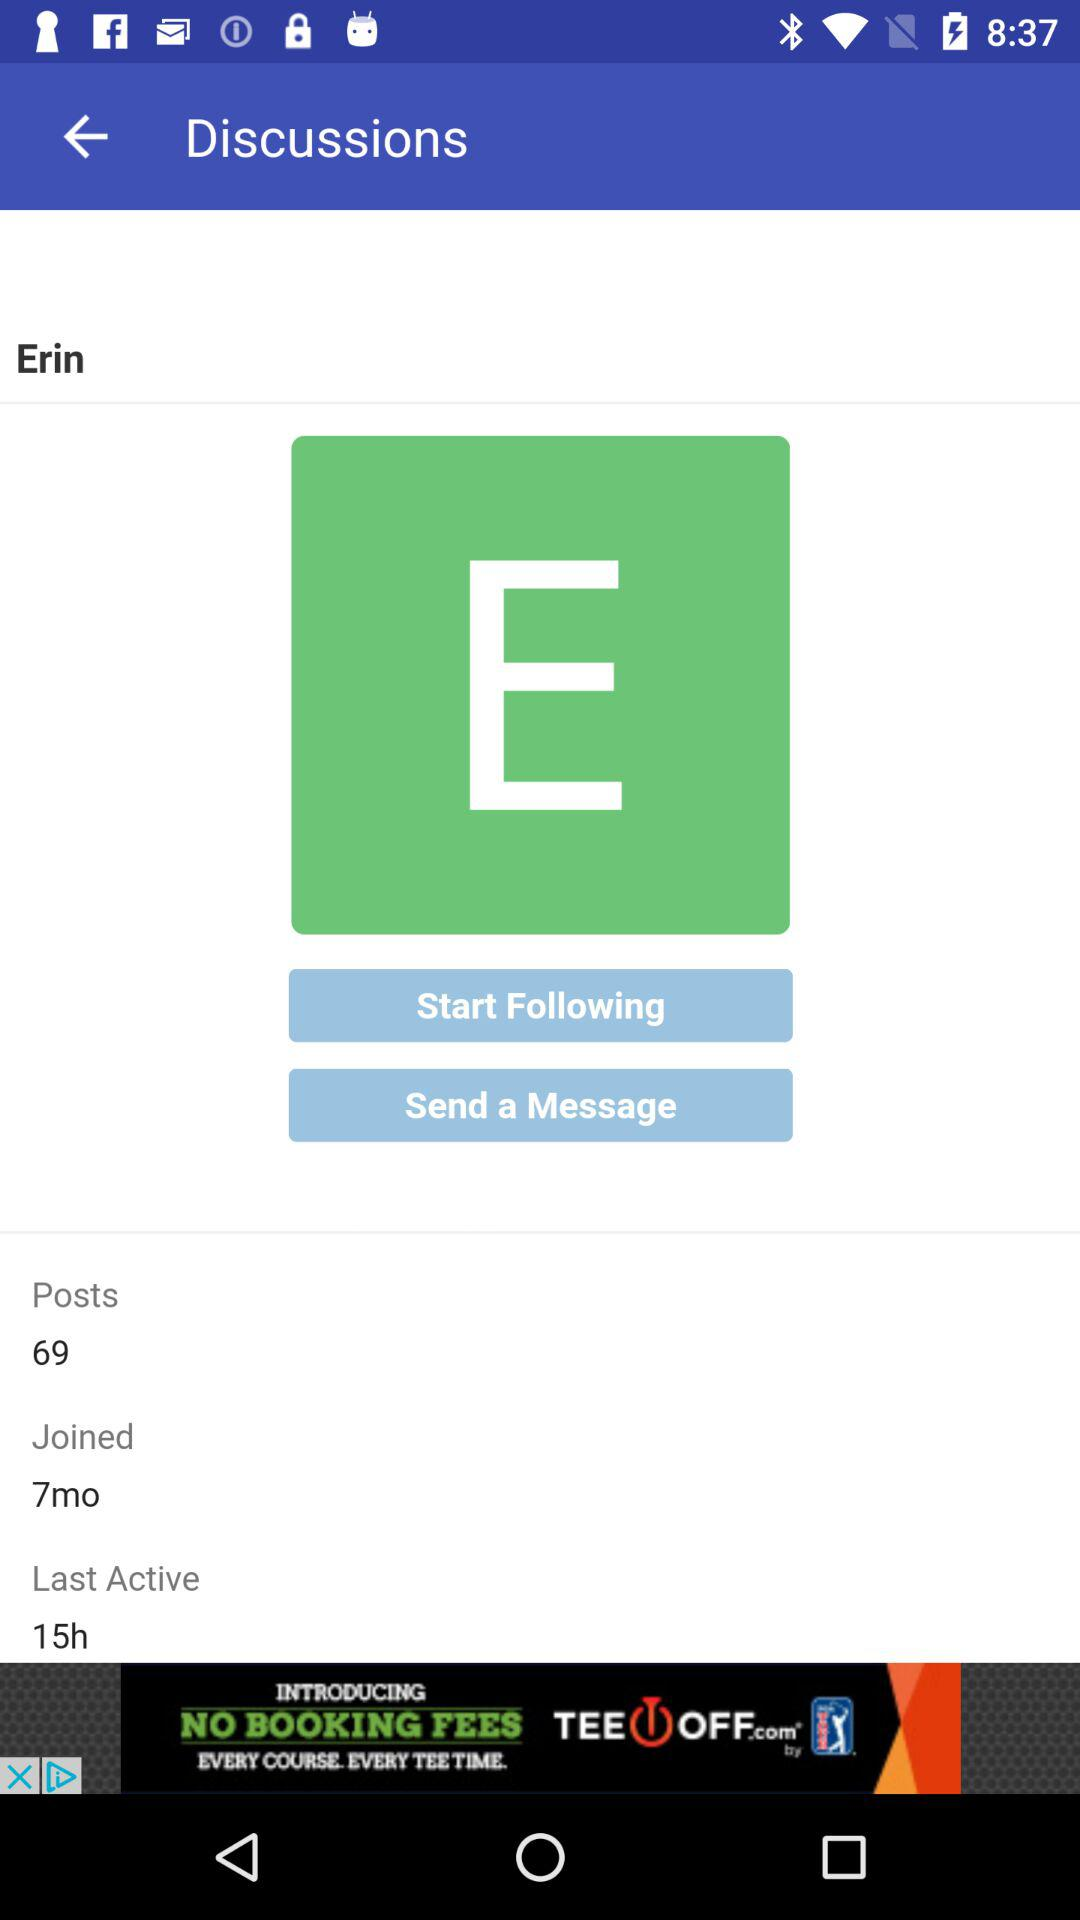What is the user name? The user name is "Erin". 